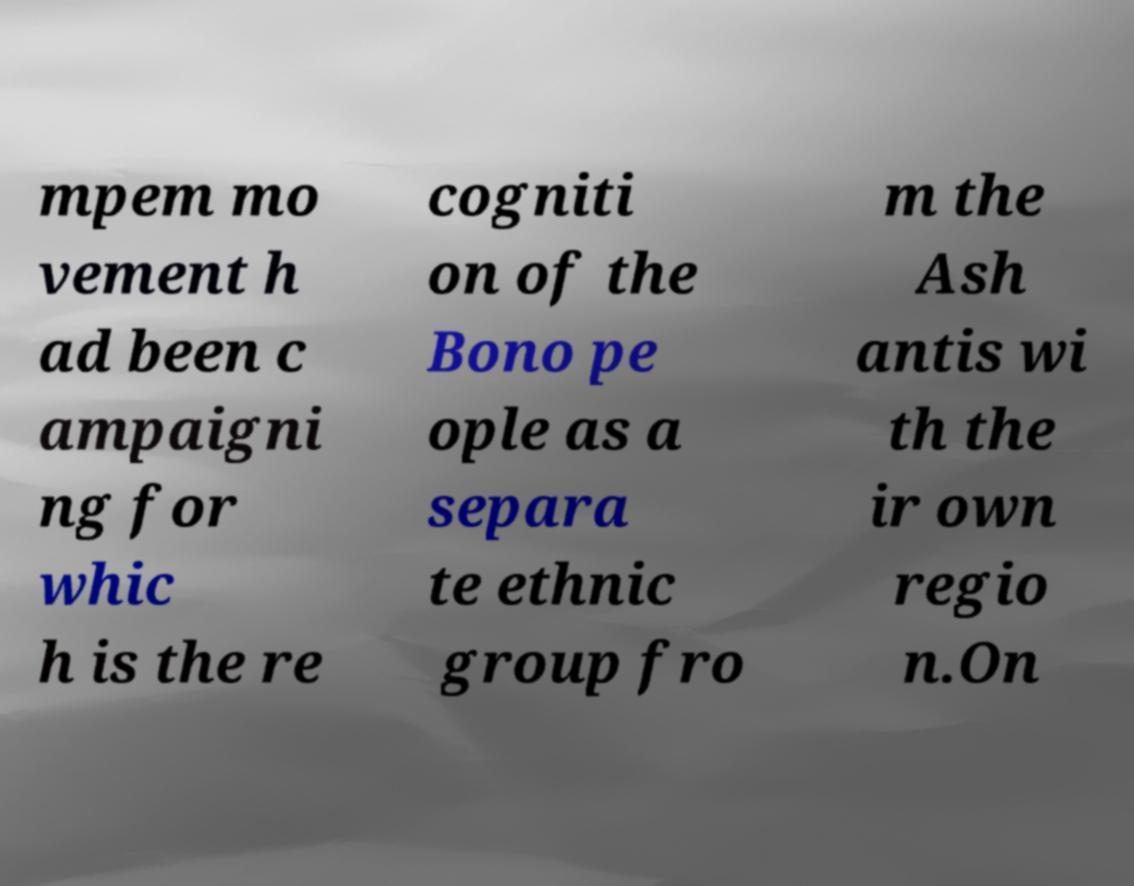Please identify and transcribe the text found in this image. mpem mo vement h ad been c ampaigni ng for whic h is the re cogniti on of the Bono pe ople as a separa te ethnic group fro m the Ash antis wi th the ir own regio n.On 